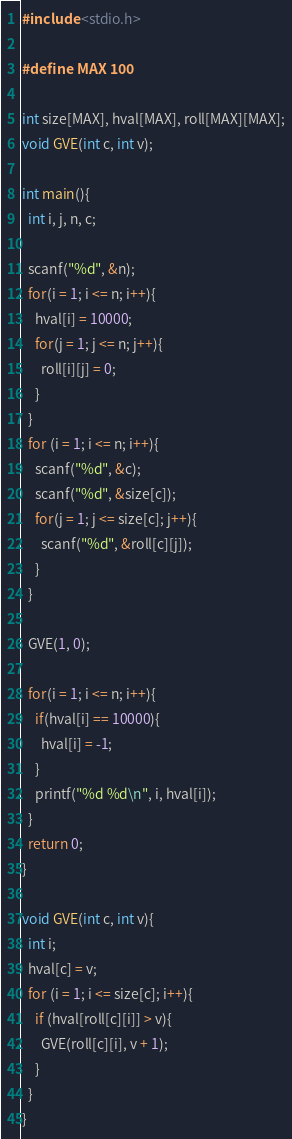<code> <loc_0><loc_0><loc_500><loc_500><_C_>#include <stdio.h>

#define MAX 100

int size[MAX], hval[MAX], roll[MAX][MAX];
void GVE(int c, int v);

int main(){
  int i, j, n, c;

  scanf("%d", &n);
  for(i = 1; i <= n; i++){
    hval[i] = 10000;
    for(j = 1; j <= n; j++){
      roll[i][j] = 0;
    }
  }
  for (i = 1; i <= n; i++){
    scanf("%d", &c);
    scanf("%d", &size[c]);
    for(j = 1; j <= size[c]; j++){
      scanf("%d", &roll[c][j]);
    }
  }

  GVE(1, 0);

  for(i = 1; i <= n; i++){
    if(hval[i] == 10000){
      hval[i] = -1;
    }
    printf("%d %d\n", i, hval[i]);
  }
  return 0;
}

void GVE(int c, int v){
  int i;
  hval[c] = v;
  for (i = 1; i <= size[c]; i++){
    if (hval[roll[c][i]] > v){
      GVE(roll[c][i], v + 1);
    }
  }
}</code> 